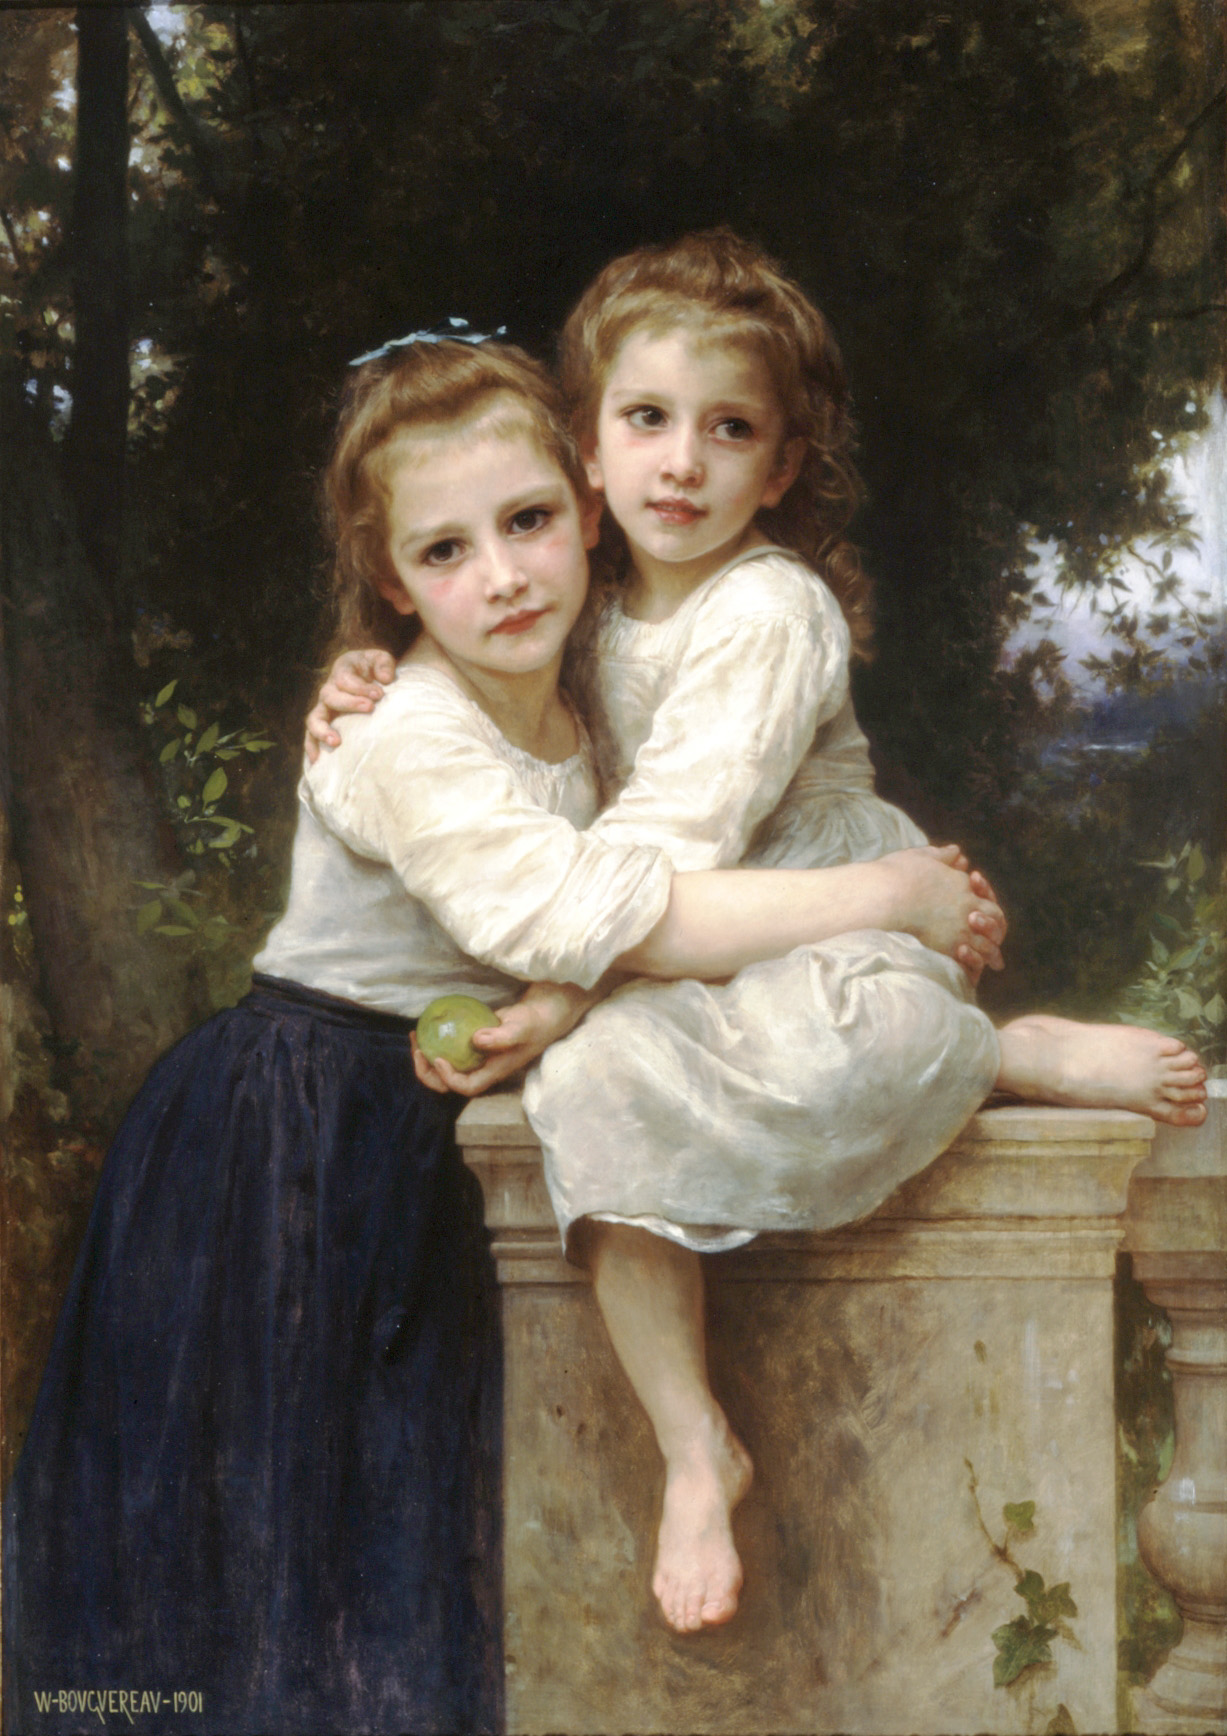Describe this scene as if it’s a moment in a historical novel. As the afternoon sun bathed the garden in a golden hue, Lady Emily and her younger sister Clara retreated to their favorite spot beyond the manor’s grand halls. Perched upon the weathered stone balustrade, they sat in gentle repose, with Emily clutching an apple, freshly plucked from the orchard. Their dresses, meticulously white and adorned with blue ribbons, fluttered softly as they shared secrets only sisters could understand. The sprawling estate behind them, with its perfectly manicured gardens and noble trees, stood in stark contrast to the tumultuous changes sweeping through 19th-century England. In this serene moment, amidst the lush foliage and tranquil ambiance of their secluded garden, the sisters found a fleeting escape from the rigid expectations and societal pressures that defined their era. It was a precious, ephemeral interlude that would echo in their memories long after they had been thrust into the complexities of adulthood and the world beyond their idyllic sanctuary. 